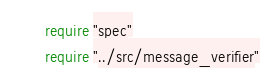Convert code to text. <code><loc_0><loc_0><loc_500><loc_500><_Crystal_>require "spec"
require "../src/message_verifier"
</code> 